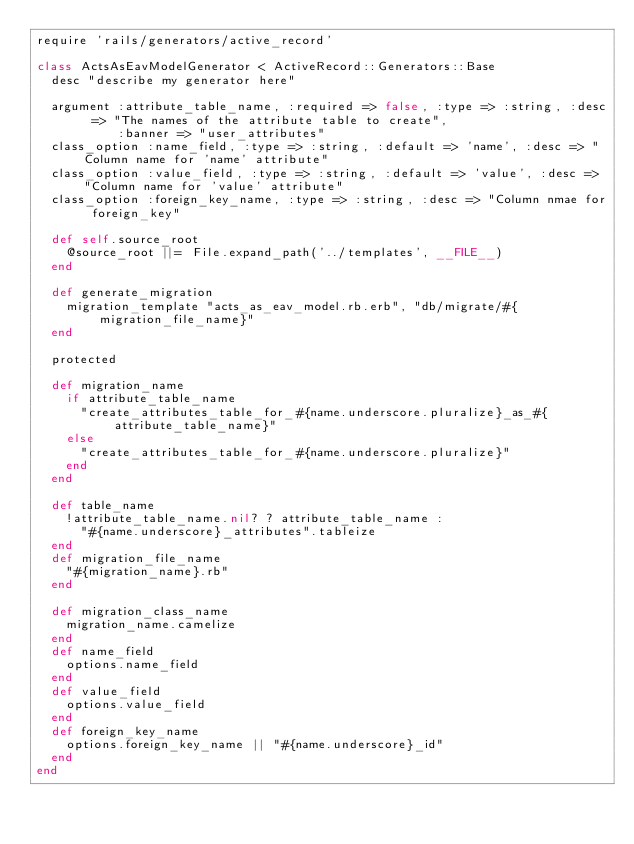Convert code to text. <code><loc_0><loc_0><loc_500><loc_500><_Ruby_>require 'rails/generators/active_record'

class ActsAsEavModelGenerator < ActiveRecord::Generators::Base
  desc "describe my generator here"

  argument :attribute_table_name, :required => false, :type => :string, :desc => "The names of the attribute table to create",
           :banner => "user_attributes"
  class_option :name_field, :type => :string, :default => 'name', :desc => "Column name for 'name' attribute"
  class_option :value_field, :type => :string, :default => 'value', :desc => "Column name for 'value' attribute"
  class_option :foreign_key_name, :type => :string, :desc => "Column nmae for foreign_key"

  def self.source_root
    @source_root ||= File.expand_path('../templates', __FILE__)
  end

  def generate_migration
    migration_template "acts_as_eav_model.rb.erb", "db/migrate/#{migration_file_name}"
  end

  protected

  def migration_name
    if attribute_table_name
      "create_attributes_table_for_#{name.underscore.pluralize}_as_#{attribute_table_name}"
    else
      "create_attributes_table_for_#{name.underscore.pluralize}"
    end
  end

  def table_name
    !attribute_table_name.nil? ? attribute_table_name :
      "#{name.underscore}_attributes".tableize
  end
  def migration_file_name
    "#{migration_name}.rb"
  end

  def migration_class_name
    migration_name.camelize
  end
  def name_field
    options.name_field
  end
  def value_field
    options.value_field
  end
  def foreign_key_name
    options.foreign_key_name || "#{name.underscore}_id"
  end
end
</code> 